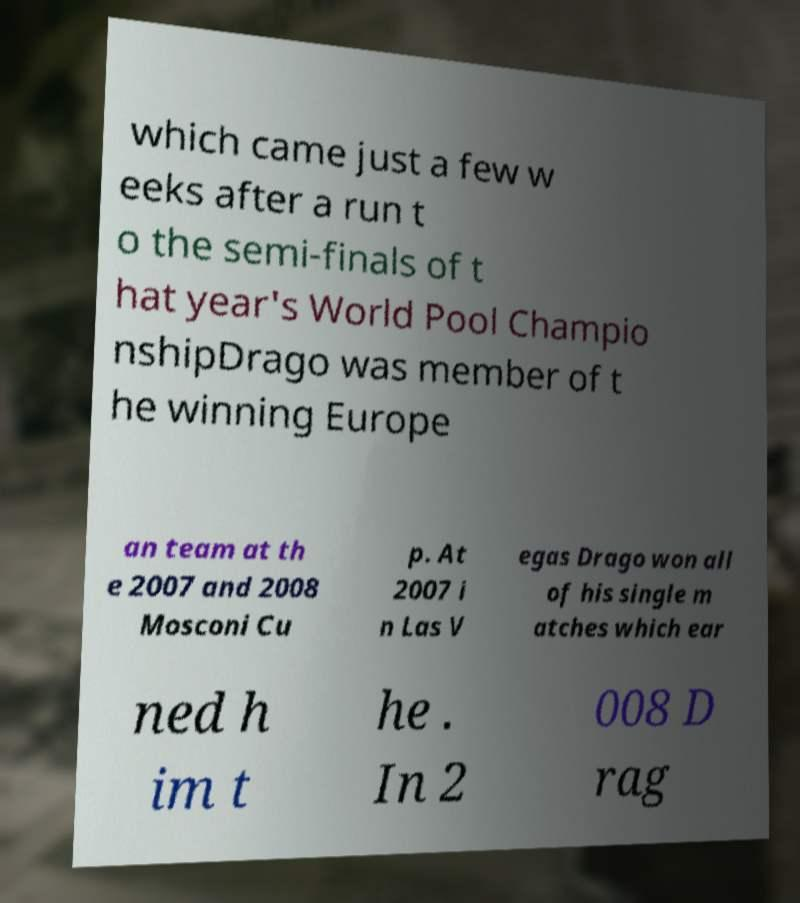Can you read and provide the text displayed in the image?This photo seems to have some interesting text. Can you extract and type it out for me? which came just a few w eeks after a run t o the semi-finals of t hat year's World Pool Champio nshipDrago was member of t he winning Europe an team at th e 2007 and 2008 Mosconi Cu p. At 2007 i n Las V egas Drago won all of his single m atches which ear ned h im t he . In 2 008 D rag 